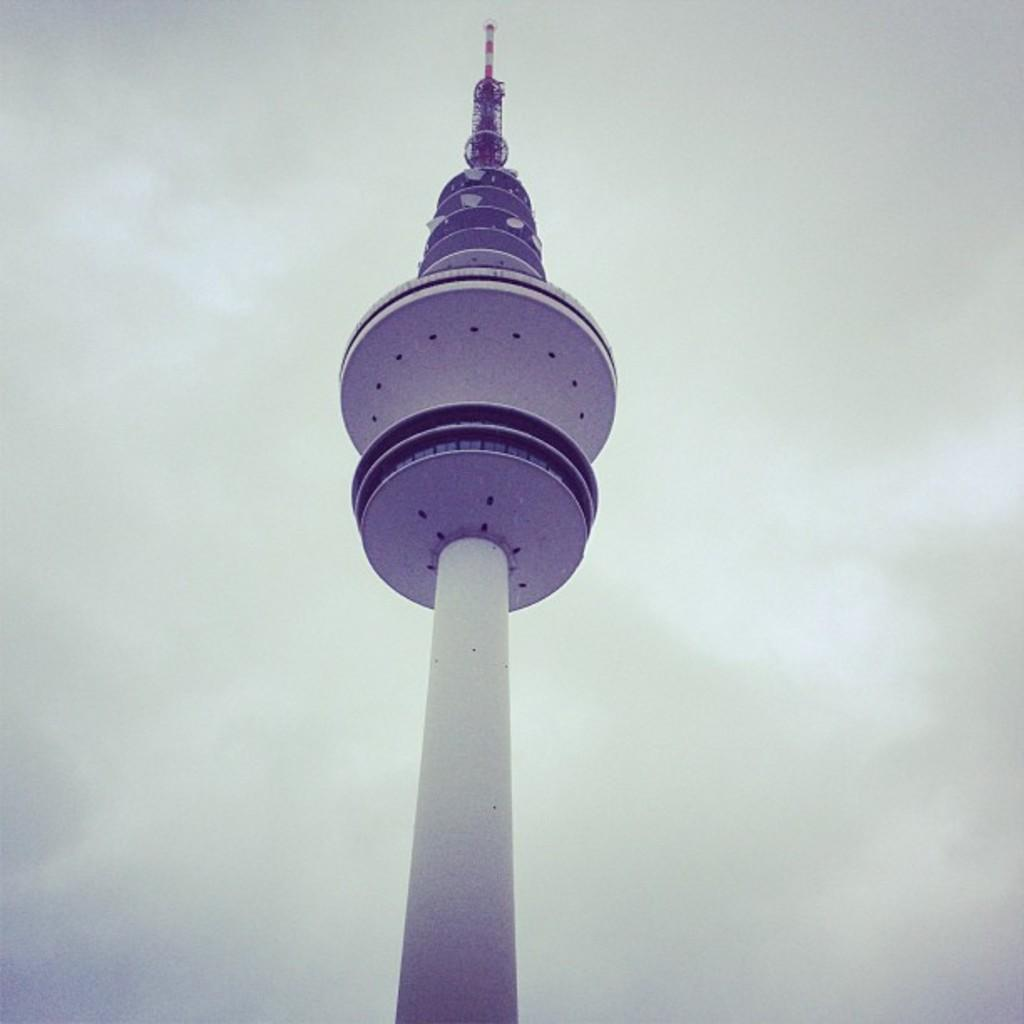What is the main structure in the image? There is a tower in the image. What can be seen in the background of the image? The sky is visible in the background of the image. What type of hair can be seen on the goat in the image? There is no goat present in the image, so there is no hair to observe. What design elements are present in the tower in the image? The facts provided do not mention any specific design elements of the tower, so we cannot answer this question definitively. 